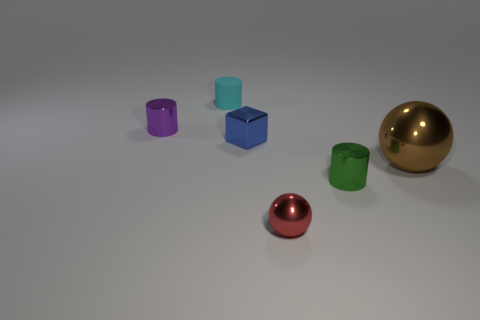Are there any other things that have the same material as the small cyan thing?
Offer a very short reply. No. Is there anything else that has the same size as the brown metal ball?
Keep it short and to the point. No. How many other objects are there of the same material as the tiny blue block?
Provide a short and direct response. 4. What is the ball right of the small cylinder in front of the small metal cylinder that is behind the big brown sphere made of?
Ensure brevity in your answer.  Metal. Does the big brown sphere have the same material as the tiny red ball?
Offer a terse response. Yes. What number of spheres are either tiny shiny things or large brown metal things?
Make the answer very short. 2. The metallic cylinder left of the tiny rubber cylinder is what color?
Give a very brief answer. Purple. What number of rubber objects are green things or tiny spheres?
Provide a short and direct response. 0. There is a thing behind the small shiny cylinder to the left of the small cyan matte cylinder; what is its material?
Your answer should be very brief. Rubber. The large object is what color?
Ensure brevity in your answer.  Brown. 